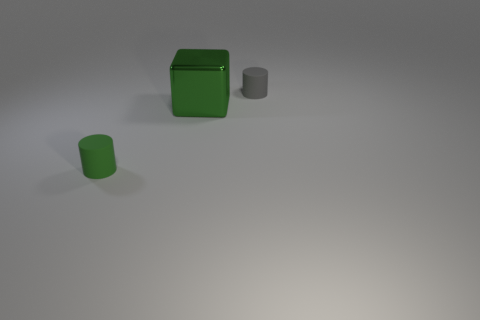There is a gray object; is its shape the same as the tiny matte thing in front of the large cube?
Provide a succinct answer. Yes. Are there an equal number of gray objects left of the green rubber cylinder and tiny gray matte objects to the right of the tiny gray cylinder?
Make the answer very short. Yes. How many other objects are the same material as the big thing?
Keep it short and to the point. 0. How many matte objects are large red cylinders or small cylinders?
Provide a succinct answer. 2. Do the small object that is on the left side of the big block and the tiny gray object have the same shape?
Provide a short and direct response. Yes. Are there more tiny green things that are in front of the big block than small green matte balls?
Provide a short and direct response. Yes. How many tiny cylinders are to the right of the green metallic cube and to the left of the gray object?
Your answer should be very brief. 0. There is a thing behind the green object on the right side of the green cylinder; what is its color?
Make the answer very short. Gray. How many other objects have the same color as the big metallic thing?
Ensure brevity in your answer.  1. There is a shiny block; is it the same color as the tiny cylinder that is right of the green rubber thing?
Your answer should be very brief. No. 